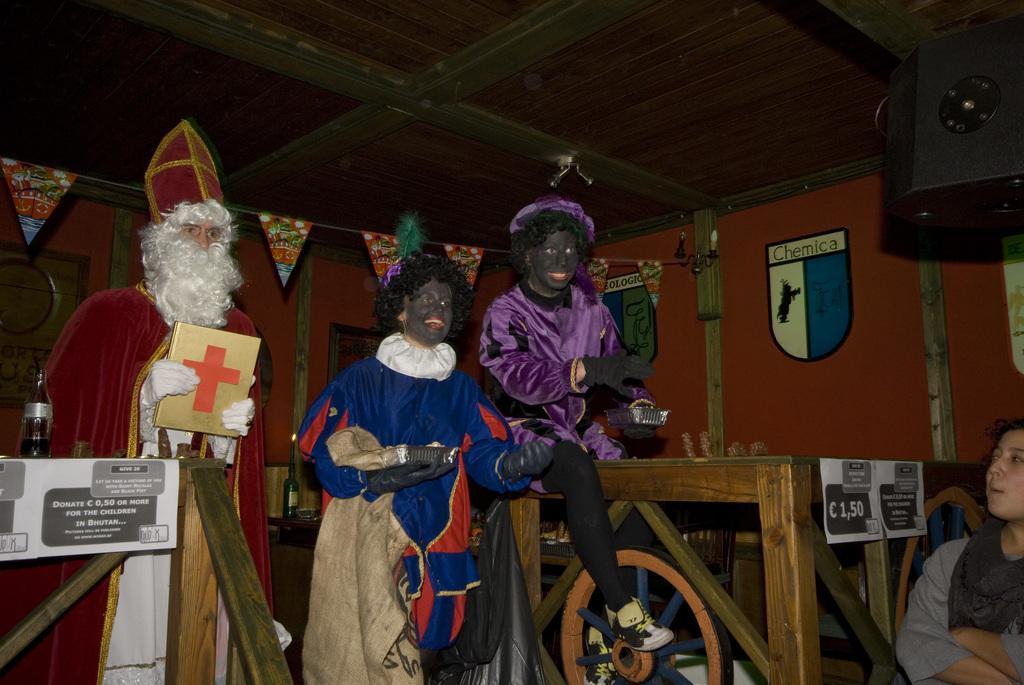Describe this image in one or two sentences. There are three people standing. They wore a fancy dress. I think they are doing a roleplay. This person is sitting on the wooden object. This looks like a table with the object on it. On the right side of the image, here is a woman sitting. This is the roof. 